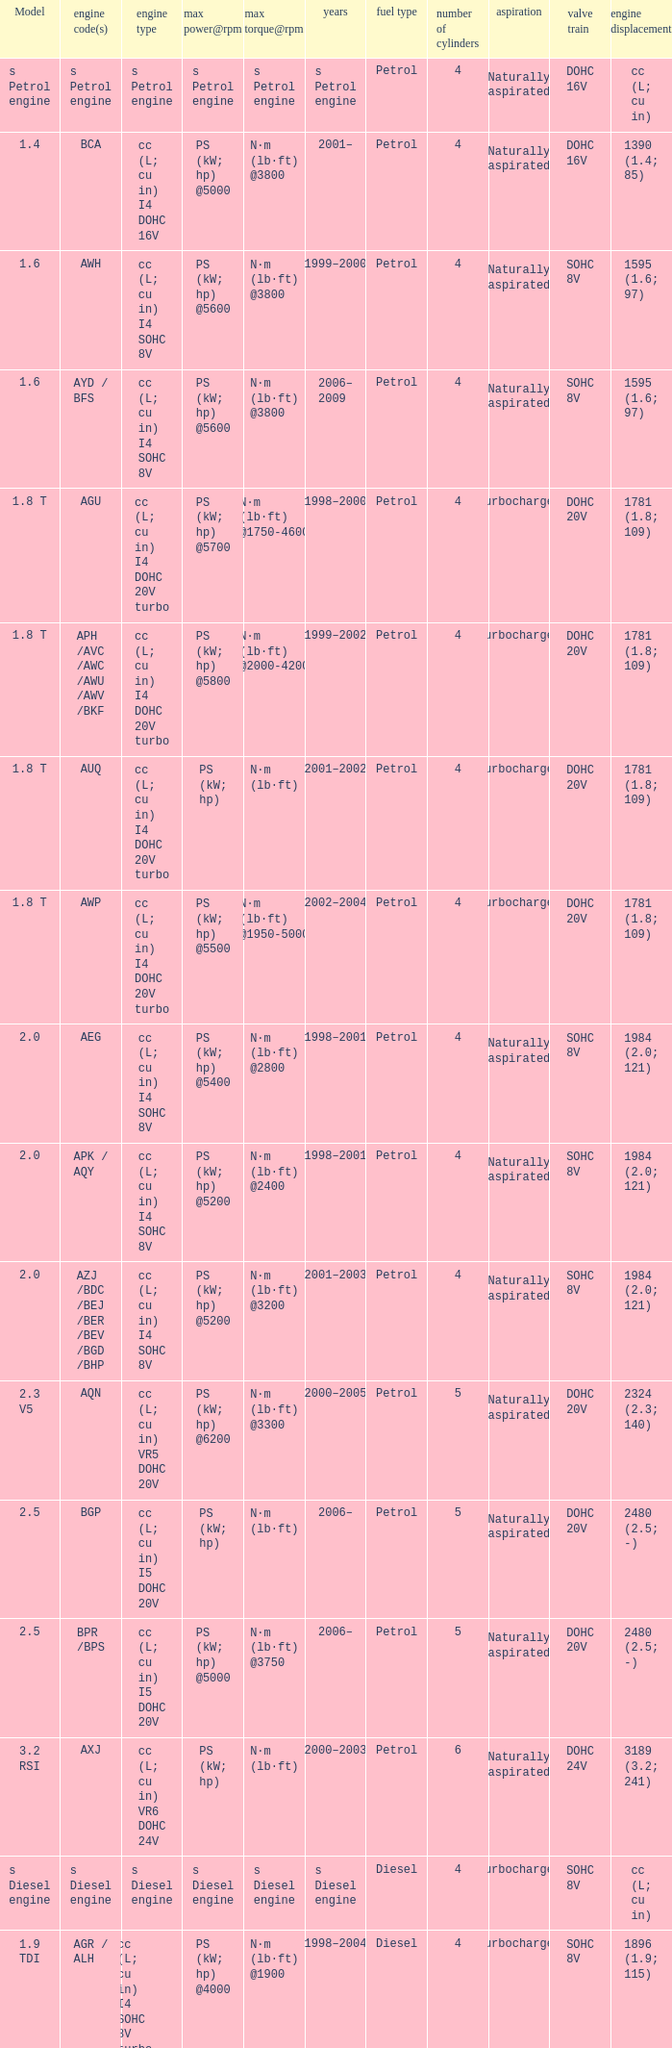Which engine type was used in the model 2.3 v5? Cc (l; cu in) vr5 dohc 20v. 